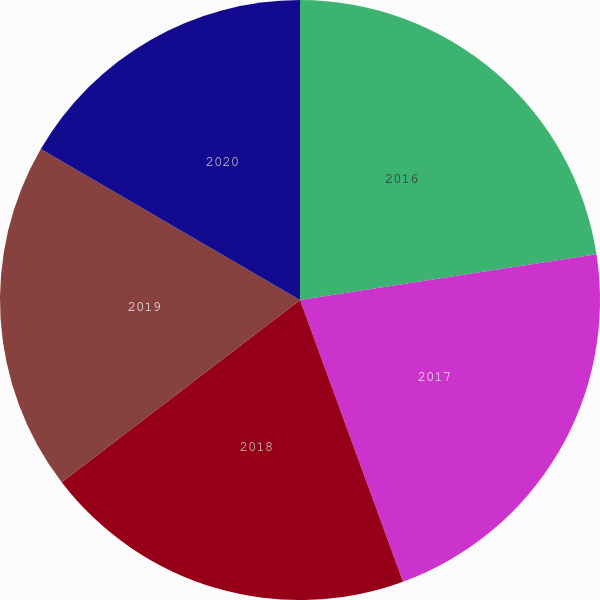Convert chart to OTSL. <chart><loc_0><loc_0><loc_500><loc_500><pie_chart><fcel>2016<fcel>2017<fcel>2018<fcel>2019<fcel>2020<nl><fcel>22.56%<fcel>21.86%<fcel>20.19%<fcel>18.79%<fcel>16.6%<nl></chart> 